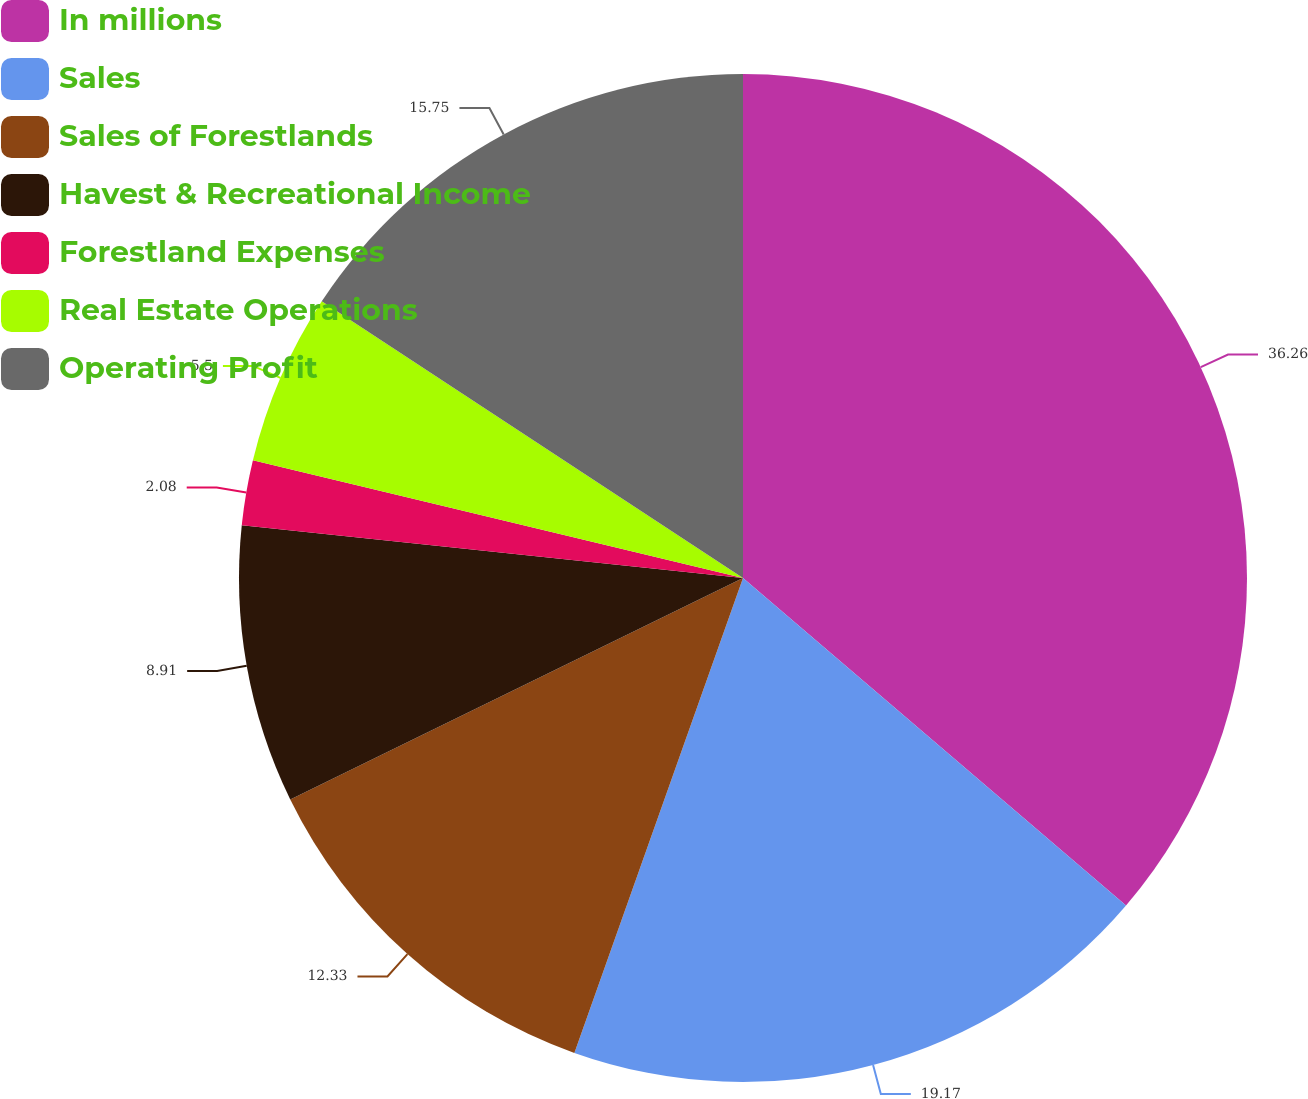Convert chart to OTSL. <chart><loc_0><loc_0><loc_500><loc_500><pie_chart><fcel>In millions<fcel>Sales<fcel>Sales of Forestlands<fcel>Havest & Recreational Income<fcel>Forestland Expenses<fcel>Real Estate Operations<fcel>Operating Profit<nl><fcel>36.26%<fcel>19.17%<fcel>12.33%<fcel>8.91%<fcel>2.08%<fcel>5.5%<fcel>15.75%<nl></chart> 